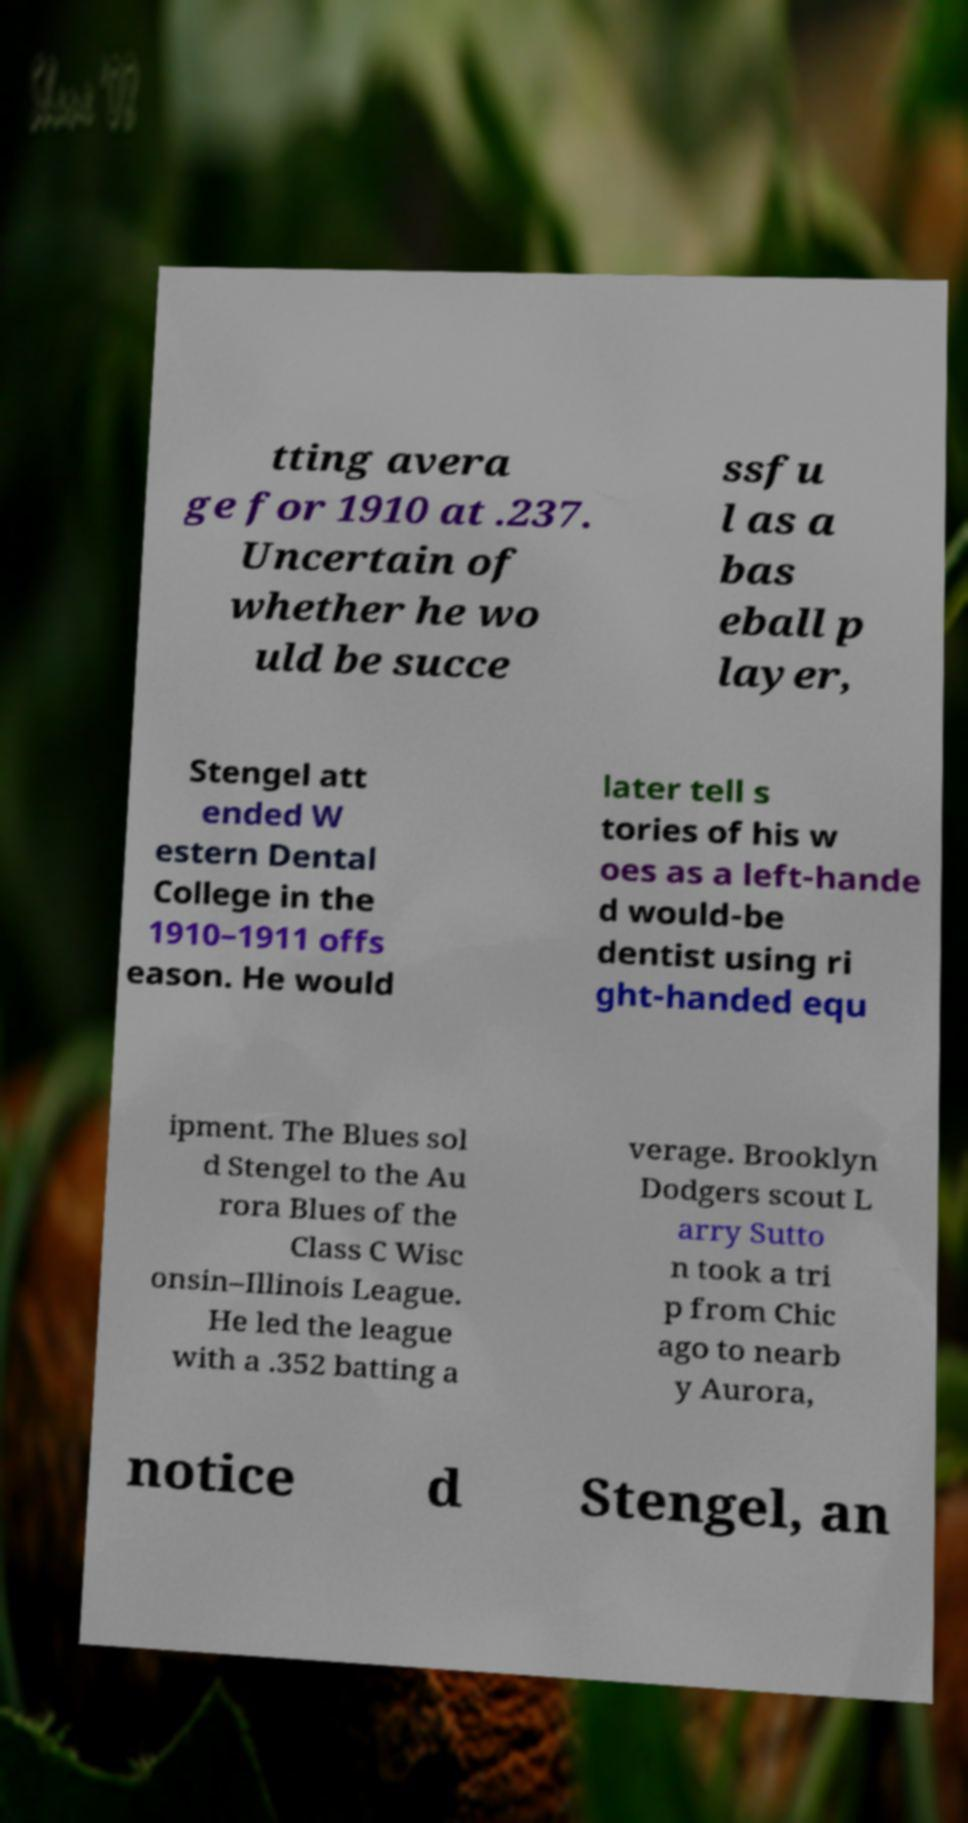Can you accurately transcribe the text from the provided image for me? tting avera ge for 1910 at .237. Uncertain of whether he wo uld be succe ssfu l as a bas eball p layer, Stengel att ended W estern Dental College in the 1910–1911 offs eason. He would later tell s tories of his w oes as a left-hande d would-be dentist using ri ght-handed equ ipment. The Blues sol d Stengel to the Au rora Blues of the Class C Wisc onsin–Illinois League. He led the league with a .352 batting a verage. Brooklyn Dodgers scout L arry Sutto n took a tri p from Chic ago to nearb y Aurora, notice d Stengel, an 